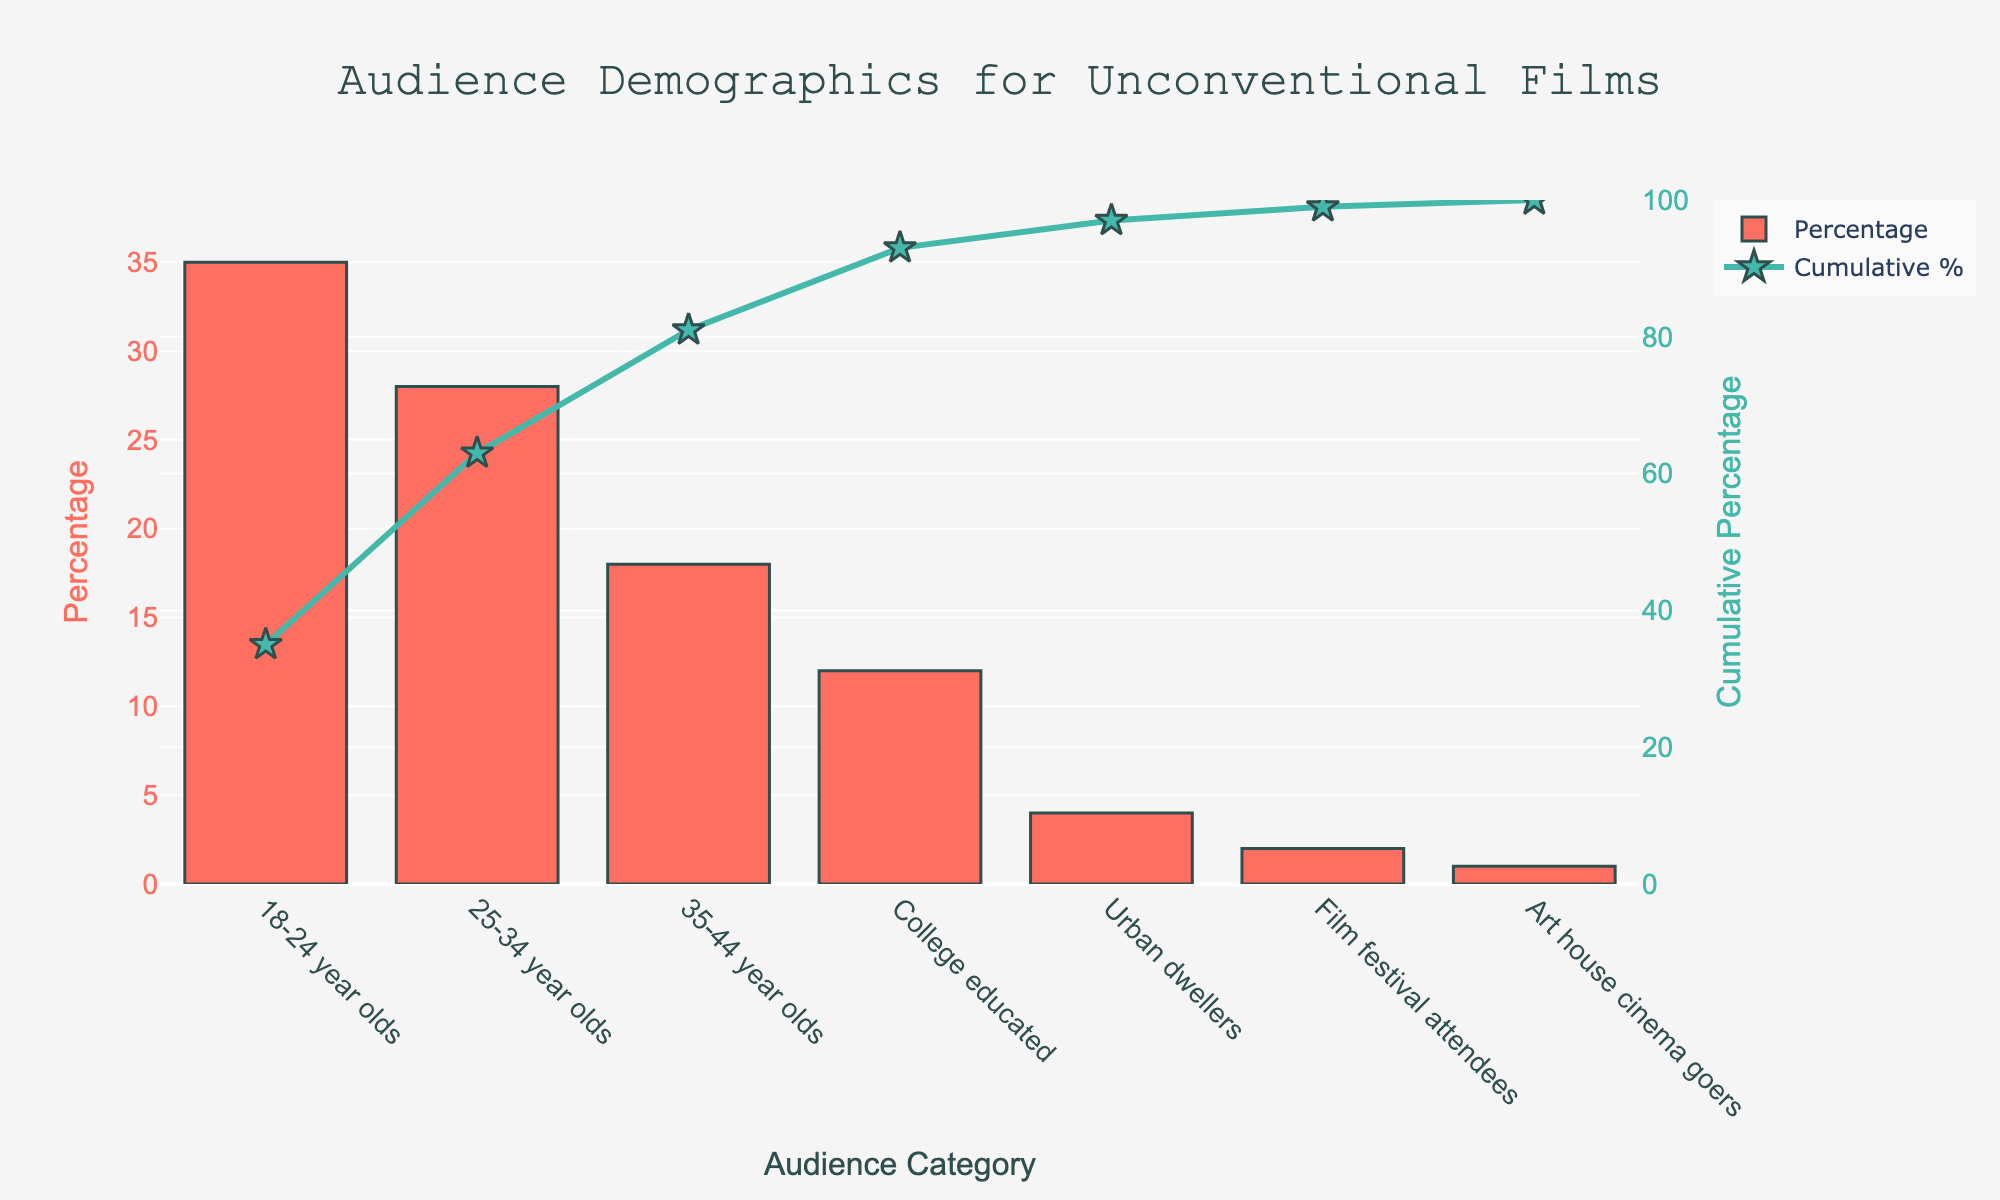what is the largest demographic group shown in the plot? The largest demographic group can be identified by looking for the tallest bar in the bar chart section of the Pareto chart. The "18-24 year olds" category has the tallest bar with 35%.
Answer: 18-24 year olds how does the cumulative percentage change from the "35-44 year olds" category to "College educated"? To find this, observe the cumulative percentage value at "35-44 year olds" and "College educated". For "35-44 year olds," it is 81% (sum of 35%, 28%, and 18%), and for "College educated," it is 93% (81% + 12%), showing an increment from 81% to 93%.
Answer: 81% to 93% which audience category contributes exactly 2% to the total percentage? Look at the percentage bars and find the one that is at 2%. The "Film festival attendees" category has a contribution of 2%.
Answer: Film festival attendees what is the combined percentage of "25-34 year olds" and "Urban dwellers"? Identify the percentages for "25-34 year olds" (28%) and "Urban dwellers" (4%) and add them together: 28% + 4% = 32%.
Answer: 32% is the percentage of "Art house cinema goers" greater than that of "Film festival attendees"? Compare the percentage values. "Art house cinema goers" is at 1%, while "Film festival attendees" is at 2%. Therefore, "Film festival attendees" has a higher percentage.
Answer: No what is the cumulative percentage up to the "Urban dwellers" category? Sum the percentages of the categories up to and including "Urban dwellers": 35% + 28% + 18% + 12% + 4% = 97%.
Answer: 97% how many audience categories have percentages below 10%? Identify categories that have percentages below 10%. They are "Urban dwellers" (4%), "Film festival attendees" (2%), and "Art house cinema goers" (1%). There are 3 such categories.
Answer: 3 which category has the second highest percentage, and how much is it? The second tallest bar after "18-24 year olds" (35%) is "25-34 year olds" with a value of 28%.
Answer: 25-34 year olds, 28% what proportion of the audience is made up of "Film festival attendees" and "Art house cinema goers" combined? Add the percentages of "Film festival attendees" (2%) and "Art house cinema goers" (1%) to get the combined proportion: 2% + 1% = 3%.
Answer: 3% are there more "College educated" or "35-44 year olds" in the audience? Compare the percentages of "College educated" (12%) and "35-44 year olds" (18%). "35-44 year olds" have a higher percentage.
Answer: 35-44 year olds 